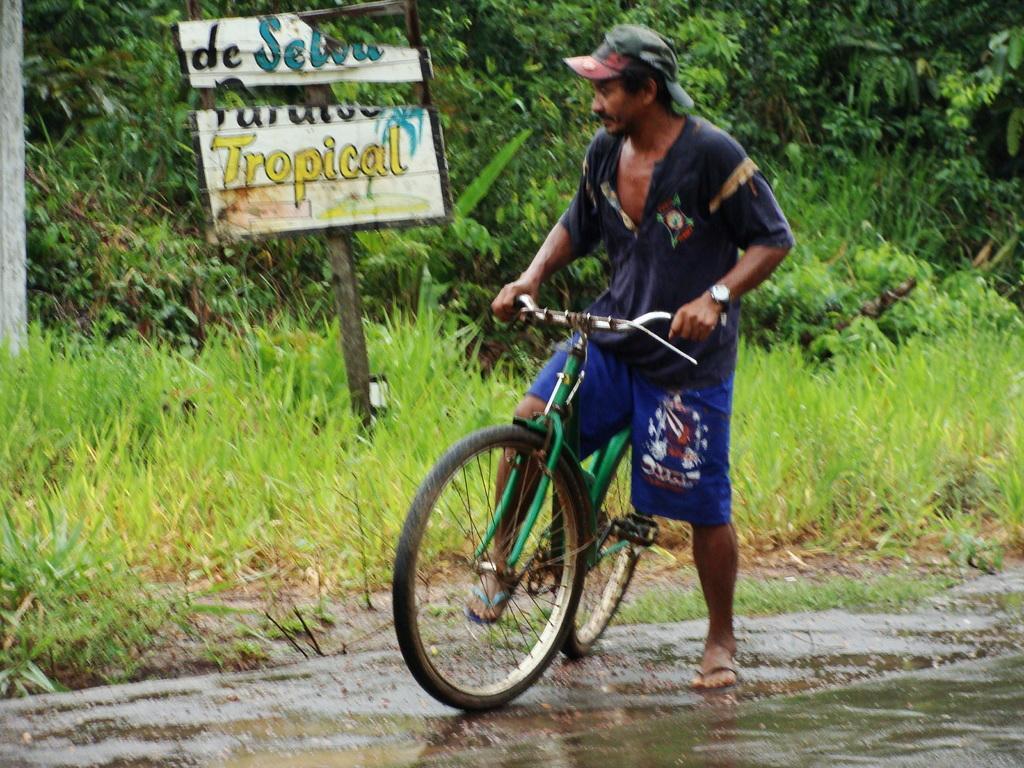Could you give a brief overview of what you see in this image? In this picture there is a man who is riding a bicycle. There is a board. There is some grass. There are few trees at the background. 